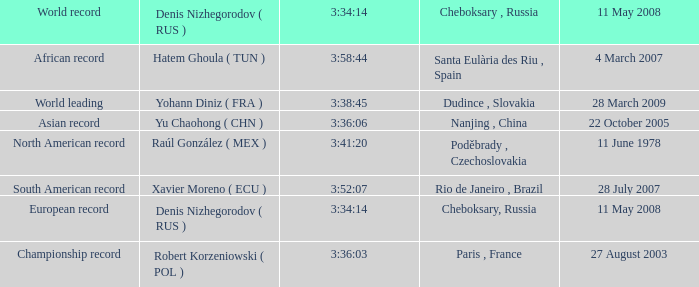When 3:38:45 is  3:34:14 what is the date on May 11th, 2008? 28 March 2009. 